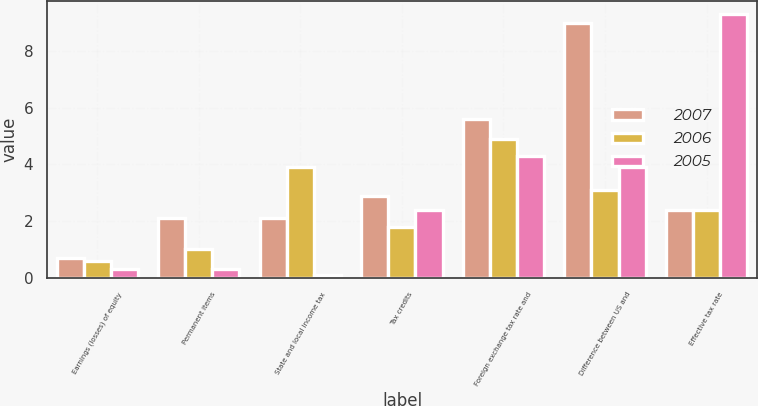Convert chart to OTSL. <chart><loc_0><loc_0><loc_500><loc_500><stacked_bar_chart><ecel><fcel>Earnings (losses) of equity<fcel>Permanent items<fcel>State and local income tax<fcel>Tax credits<fcel>Foreign exchange tax rate and<fcel>Difference between US and<fcel>Effective tax rate<nl><fcel>2007<fcel>0.7<fcel>2.1<fcel>2.1<fcel>2.9<fcel>5.6<fcel>9<fcel>2.4<nl><fcel>2006<fcel>0.6<fcel>1<fcel>3.9<fcel>1.8<fcel>4.9<fcel>3.1<fcel>2.4<nl><fcel>2005<fcel>0.3<fcel>0.3<fcel>0.1<fcel>2.4<fcel>4.3<fcel>3.9<fcel>9.3<nl></chart> 